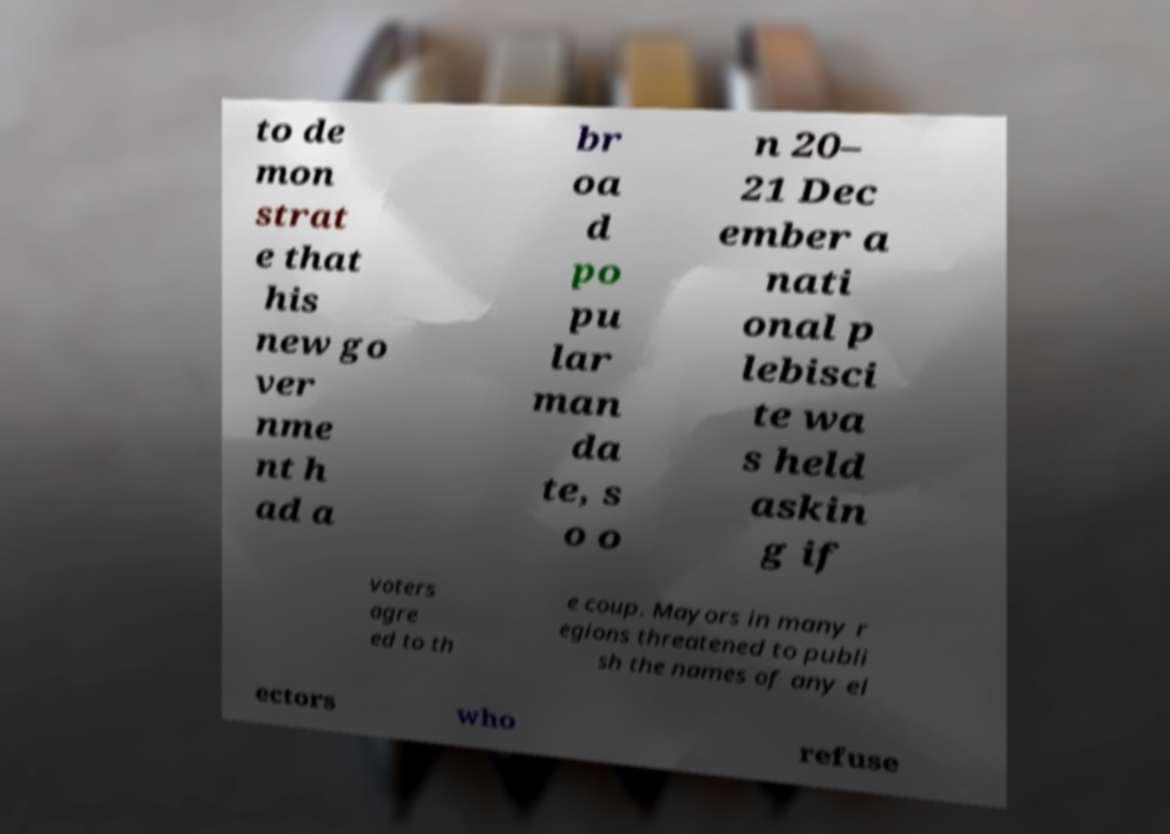Can you read and provide the text displayed in the image?This photo seems to have some interesting text. Can you extract and type it out for me? to de mon strat e that his new go ver nme nt h ad a br oa d po pu lar man da te, s o o n 20– 21 Dec ember a nati onal p lebisci te wa s held askin g if voters agre ed to th e coup. Mayors in many r egions threatened to publi sh the names of any el ectors who refuse 